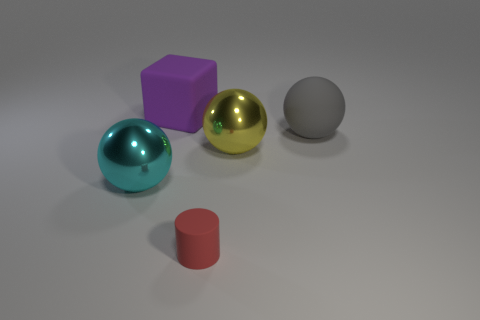What is the color of the object that is both behind the small cylinder and in front of the yellow metallic thing? cyan 